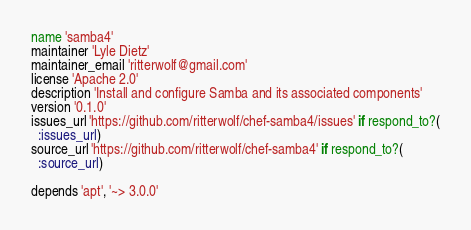Convert code to text. <code><loc_0><loc_0><loc_500><loc_500><_Ruby_>name 'samba4'
maintainer 'Lyle Dietz'
maintainer_email 'ritterwolf@gmail.com'
license 'Apache 2.0'
description 'Install and configure Samba and its associated components'
version '0.1.0'
issues_url 'https://github.com/ritterwolf/chef-samba4/issues' if respond_to?(
  :issues_url)
source_url 'https://github.com/ritterwolf/chef-samba4' if respond_to?(
  :source_url)

depends 'apt', '~> 3.0.0'
</code> 